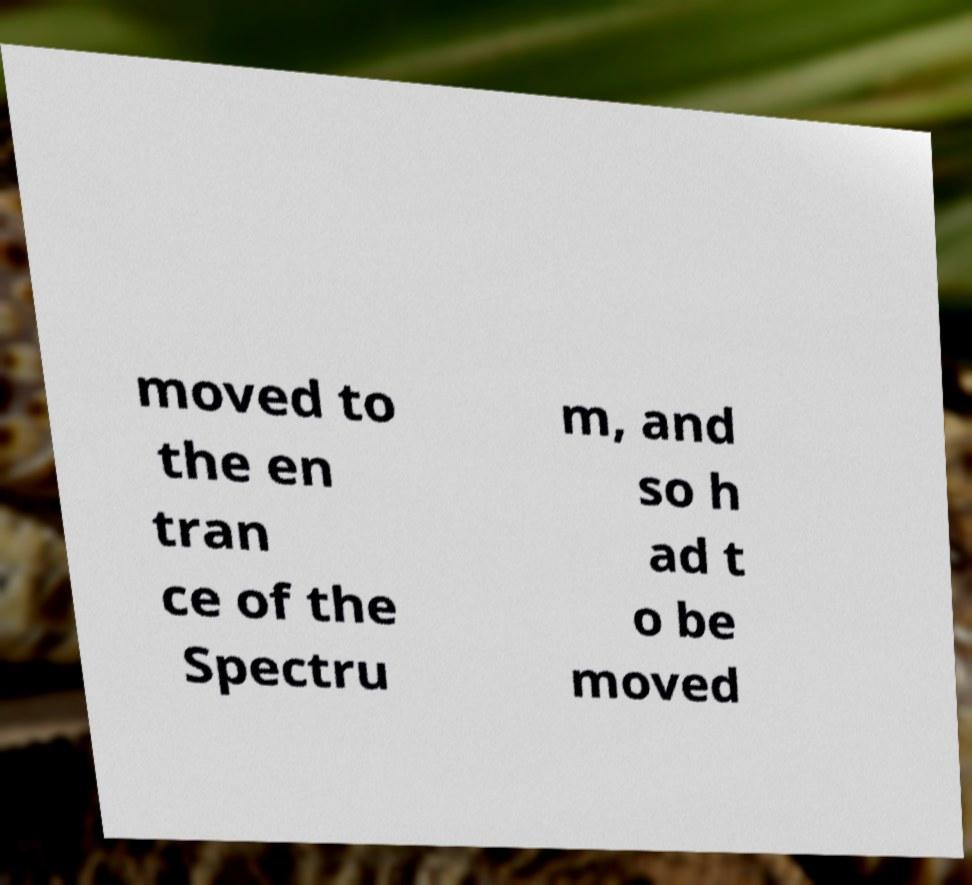Could you assist in decoding the text presented in this image and type it out clearly? moved to the en tran ce of the Spectru m, and so h ad t o be moved 